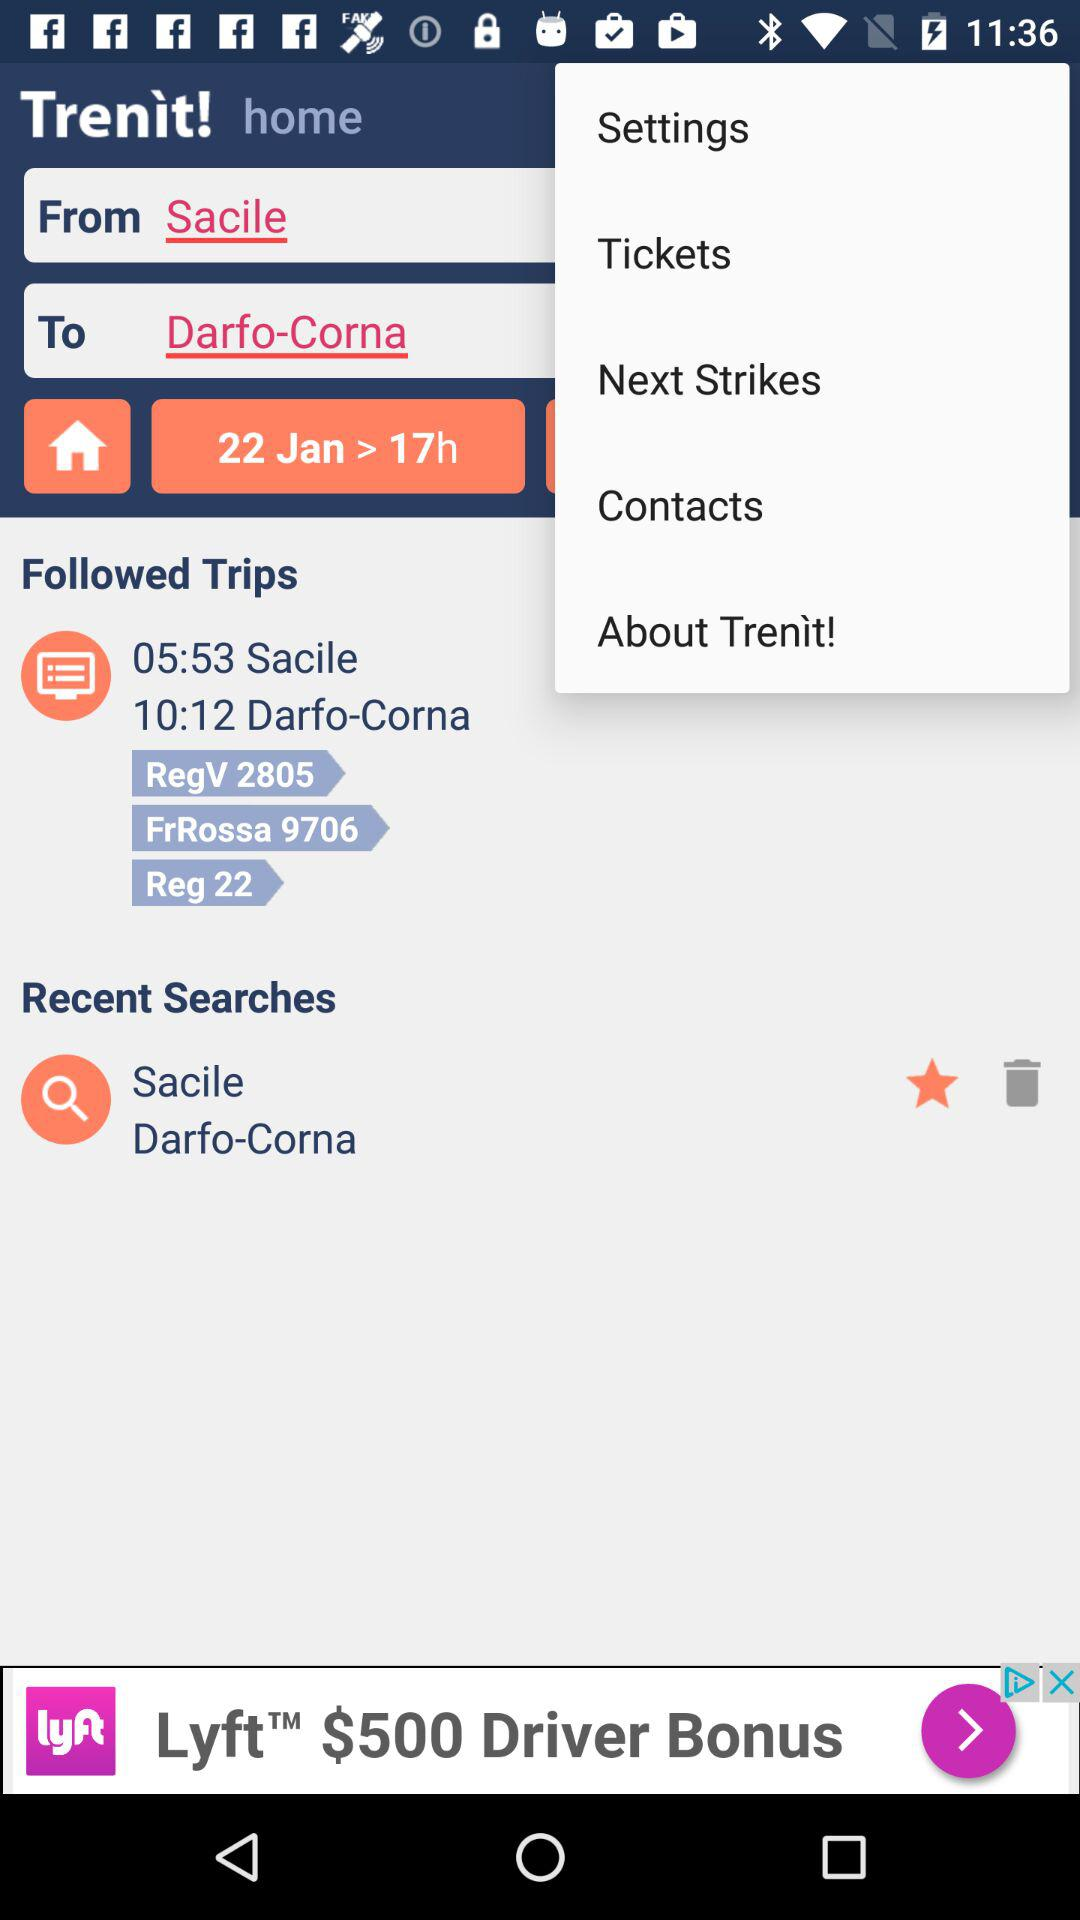What's the scheduled date of the trip? The scheduled date of the trip is January 22. 